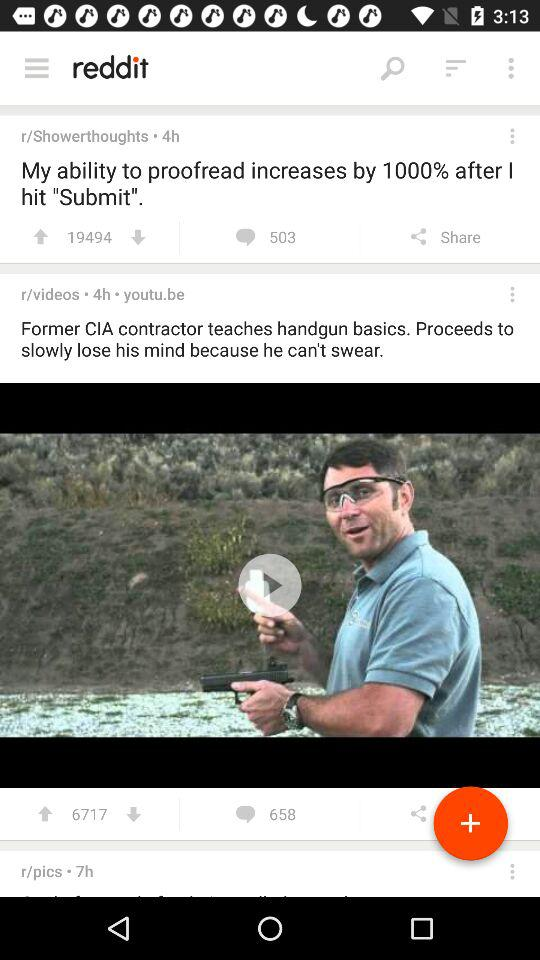When was the post posted by r/Showerthoughts? The post was posted by r/Showerthoughts four hours ago. 